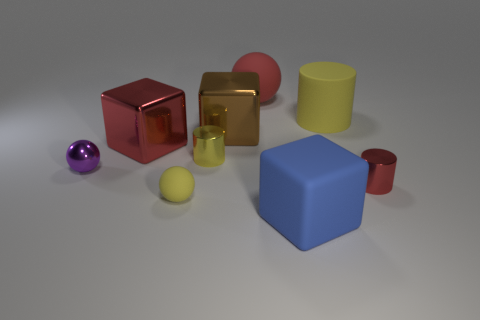Subtract all green blocks. Subtract all purple spheres. How many blocks are left? 3 Add 1 small metallic objects. How many objects exist? 10 Subtract all cubes. How many objects are left? 6 Add 9 tiny metal balls. How many tiny metal balls exist? 10 Subtract 0 green cylinders. How many objects are left? 9 Subtract all large blue metal cubes. Subtract all large blue rubber things. How many objects are left? 8 Add 7 tiny yellow things. How many tiny yellow things are left? 9 